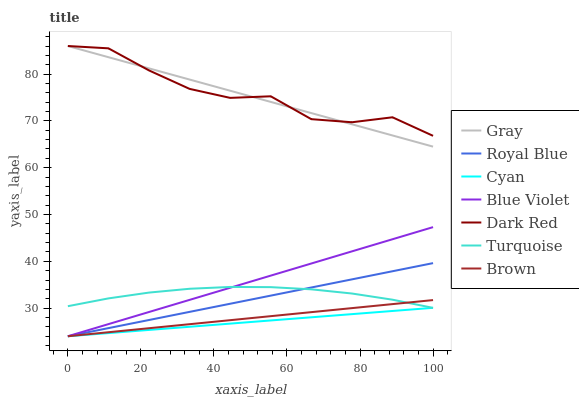Does Cyan have the minimum area under the curve?
Answer yes or no. Yes. Does Dark Red have the maximum area under the curve?
Answer yes or no. Yes. Does Turquoise have the minimum area under the curve?
Answer yes or no. No. Does Turquoise have the maximum area under the curve?
Answer yes or no. No. Is Cyan the smoothest?
Answer yes or no. Yes. Is Dark Red the roughest?
Answer yes or no. Yes. Is Turquoise the smoothest?
Answer yes or no. No. Is Turquoise the roughest?
Answer yes or no. No. Does Brown have the lowest value?
Answer yes or no. Yes. Does Turquoise have the lowest value?
Answer yes or no. No. Does Dark Red have the highest value?
Answer yes or no. Yes. Does Turquoise have the highest value?
Answer yes or no. No. Is Brown less than Dark Red?
Answer yes or no. Yes. Is Dark Red greater than Cyan?
Answer yes or no. Yes. Does Blue Violet intersect Cyan?
Answer yes or no. Yes. Is Blue Violet less than Cyan?
Answer yes or no. No. Is Blue Violet greater than Cyan?
Answer yes or no. No. Does Brown intersect Dark Red?
Answer yes or no. No. 